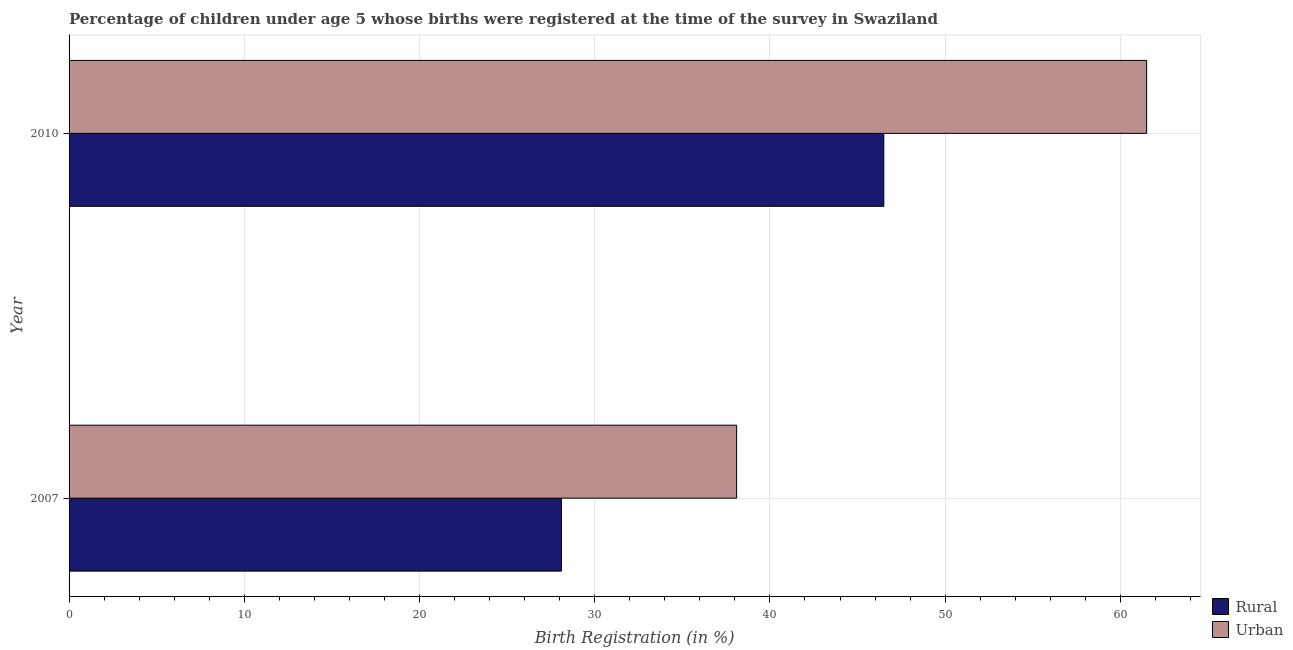How many different coloured bars are there?
Provide a short and direct response. 2. What is the rural birth registration in 2010?
Your answer should be compact. 46.5. Across all years, what is the maximum rural birth registration?
Provide a short and direct response. 46.5. Across all years, what is the minimum rural birth registration?
Your answer should be compact. 28.1. In which year was the rural birth registration maximum?
Provide a short and direct response. 2010. What is the total rural birth registration in the graph?
Ensure brevity in your answer.  74.6. What is the difference between the urban birth registration in 2007 and that in 2010?
Make the answer very short. -23.4. What is the difference between the urban birth registration in 2010 and the rural birth registration in 2007?
Ensure brevity in your answer.  33.4. What is the average rural birth registration per year?
Provide a short and direct response. 37.3. In the year 2010, what is the difference between the rural birth registration and urban birth registration?
Your response must be concise. -15. What is the ratio of the rural birth registration in 2007 to that in 2010?
Keep it short and to the point. 0.6. Is the difference between the urban birth registration in 2007 and 2010 greater than the difference between the rural birth registration in 2007 and 2010?
Provide a succinct answer. No. What does the 2nd bar from the top in 2007 represents?
Ensure brevity in your answer.  Rural. What does the 1st bar from the bottom in 2007 represents?
Keep it short and to the point. Rural. Are all the bars in the graph horizontal?
Make the answer very short. Yes. What is the difference between two consecutive major ticks on the X-axis?
Make the answer very short. 10. Are the values on the major ticks of X-axis written in scientific E-notation?
Provide a succinct answer. No. Does the graph contain grids?
Make the answer very short. Yes. How many legend labels are there?
Give a very brief answer. 2. What is the title of the graph?
Offer a very short reply. Percentage of children under age 5 whose births were registered at the time of the survey in Swaziland. What is the label or title of the X-axis?
Provide a succinct answer. Birth Registration (in %). What is the Birth Registration (in %) of Rural in 2007?
Ensure brevity in your answer.  28.1. What is the Birth Registration (in %) of Urban in 2007?
Provide a short and direct response. 38.1. What is the Birth Registration (in %) in Rural in 2010?
Keep it short and to the point. 46.5. What is the Birth Registration (in %) in Urban in 2010?
Your answer should be very brief. 61.5. Across all years, what is the maximum Birth Registration (in %) in Rural?
Provide a succinct answer. 46.5. Across all years, what is the maximum Birth Registration (in %) of Urban?
Offer a terse response. 61.5. Across all years, what is the minimum Birth Registration (in %) of Rural?
Provide a succinct answer. 28.1. Across all years, what is the minimum Birth Registration (in %) in Urban?
Provide a succinct answer. 38.1. What is the total Birth Registration (in %) of Rural in the graph?
Your response must be concise. 74.6. What is the total Birth Registration (in %) of Urban in the graph?
Provide a short and direct response. 99.6. What is the difference between the Birth Registration (in %) of Rural in 2007 and that in 2010?
Give a very brief answer. -18.4. What is the difference between the Birth Registration (in %) in Urban in 2007 and that in 2010?
Ensure brevity in your answer.  -23.4. What is the difference between the Birth Registration (in %) in Rural in 2007 and the Birth Registration (in %) in Urban in 2010?
Provide a short and direct response. -33.4. What is the average Birth Registration (in %) of Rural per year?
Offer a very short reply. 37.3. What is the average Birth Registration (in %) in Urban per year?
Your answer should be compact. 49.8. What is the ratio of the Birth Registration (in %) of Rural in 2007 to that in 2010?
Offer a very short reply. 0.6. What is the ratio of the Birth Registration (in %) in Urban in 2007 to that in 2010?
Give a very brief answer. 0.62. What is the difference between the highest and the second highest Birth Registration (in %) in Urban?
Make the answer very short. 23.4. What is the difference between the highest and the lowest Birth Registration (in %) of Rural?
Ensure brevity in your answer.  18.4. What is the difference between the highest and the lowest Birth Registration (in %) in Urban?
Your response must be concise. 23.4. 